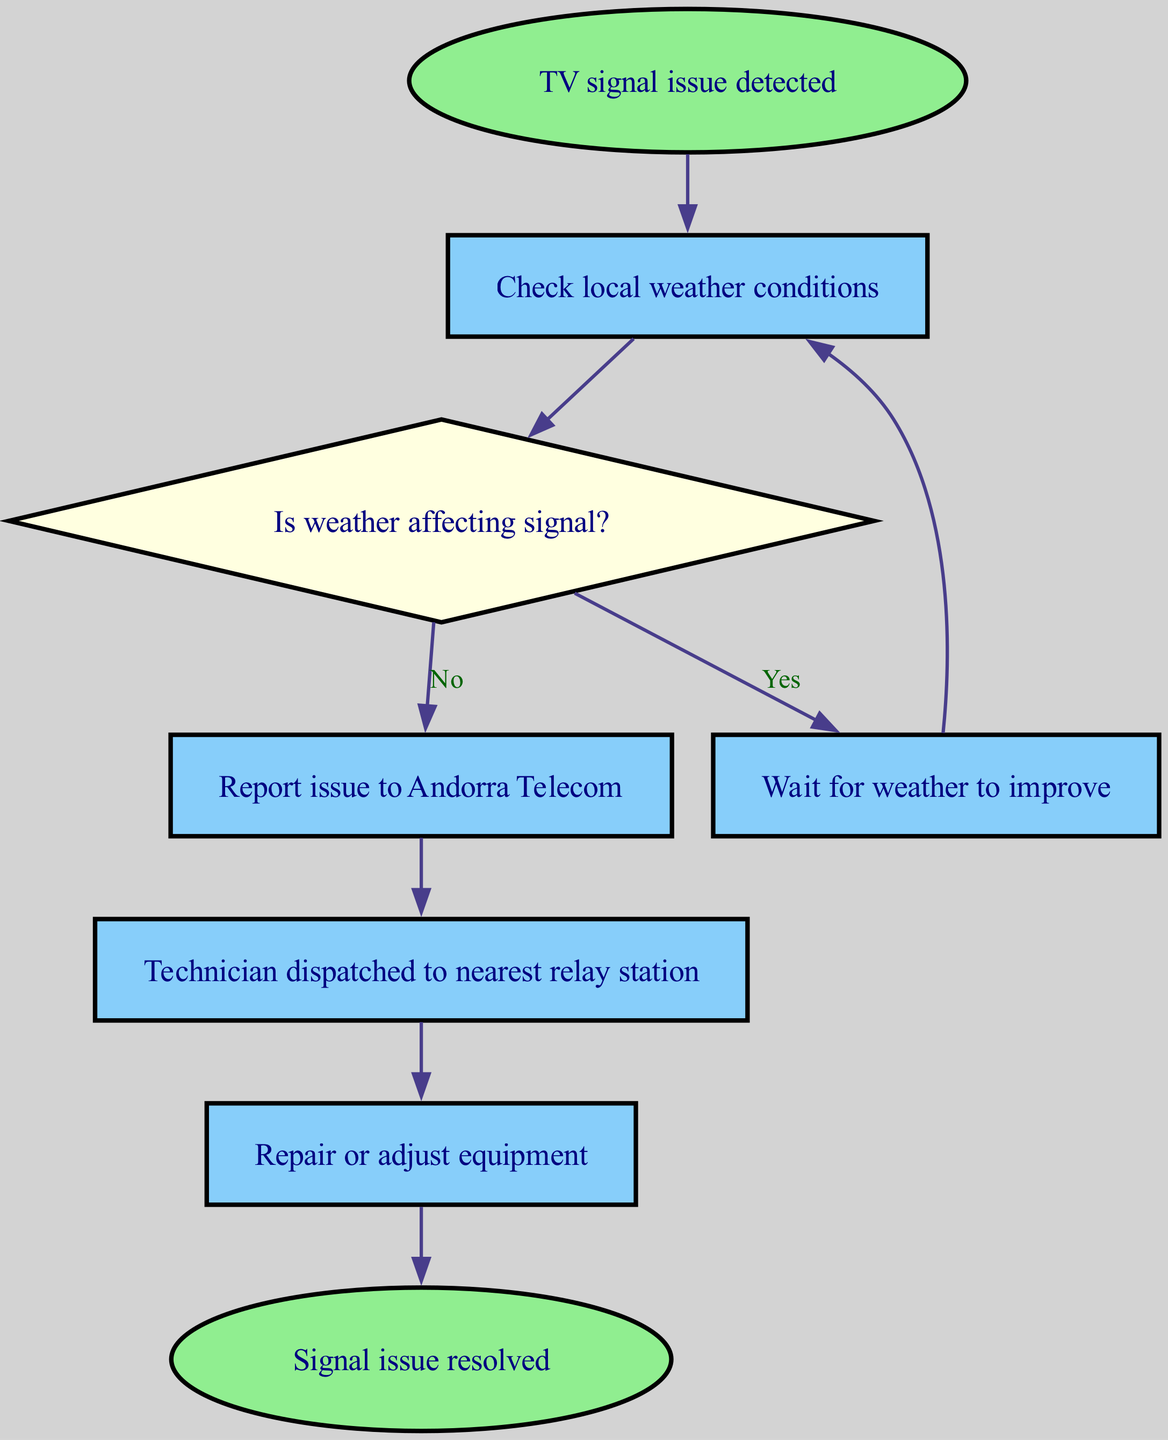What is the first step when a TV signal issue is detected? The flowchart indicates that the first step is to detect the TV signal issue, which is represented in the node labeled "TV signal issue detected."
Answer: TV signal issue detected How many nodes are present in the workflow? Counting the nodes listed, there are a total of 8 nodes, which include the start, check, weather, wait, report, technician, repair, and resolved.
Answer: 8 What action is taken if the weather is affecting the signal? According to the flowchart, if the weather is affecting the signal, the workflow directs to the "Wait for weather to improve" node.
Answer: Wait for weather to improve What happens after the technician is dispatched? After the technician is dispatched to the nearest relay station, the next action in the workflow is to "Repair or adjust equipment."
Answer: Repair or adjust equipment If weather is not affecting the signal, what should be reported? The workflow specifies that if the weather is not affecting the signal, the issue should be reported to Andorra Telecom, leading to that node.
Answer: Report issue to Andorra Telecom What node represents the resolution of the signal issue? The resolution of the signal issue is represented in the node labeled "Signal issue resolved."
Answer: Signal issue resolved What follows after waiting for weather conditions to improve? After waiting for the weather conditions to improve, the next step is to "Check local weather conditions" again, indicating a loop back to assess the situation.
Answer: Check local weather conditions How many edges connect the nodes in the flowchart? The flowchart indicates there are a total of 7 edges connecting the nodes, as each step leads to another action or decision point.
Answer: 7 